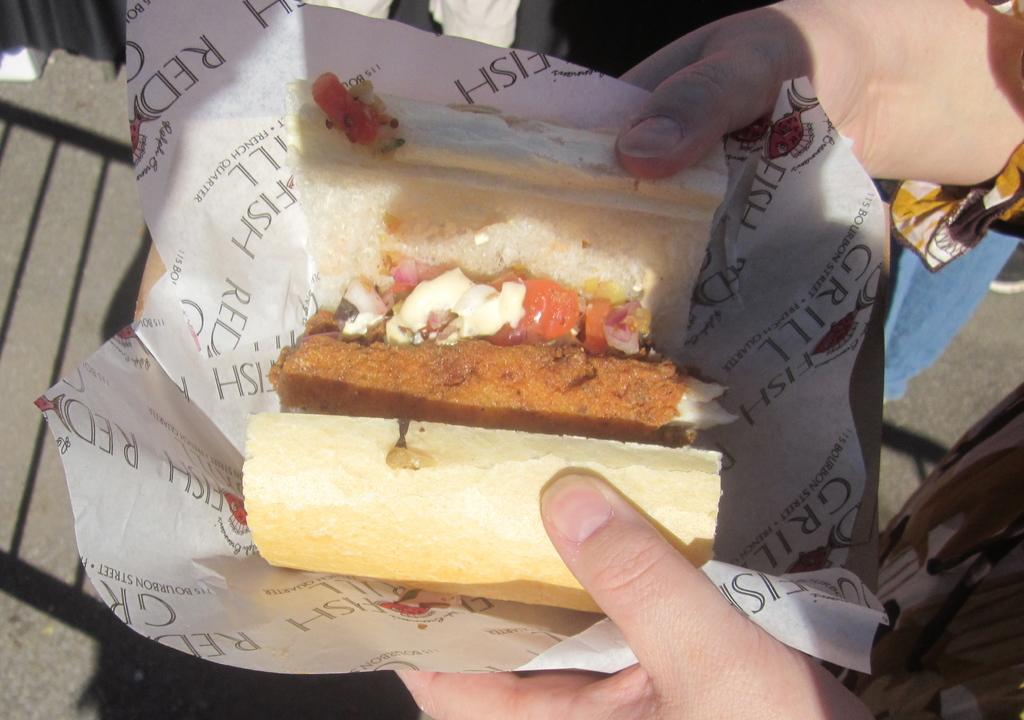Who or what is present in the image? There is a person in the image. What is the person holding in the image? The person is holding a paper. What can be seen on the paper that the person is holding? The paper contains images of food. What part of the person's body is visible in the image? The person's legs are visible in the image. What type of object can be seen in the background of the image? There is a black color curtain in the image. What color is the sweater the person is wearing in the image? The provided facts do not mention a sweater, so we cannot determine the color of a sweater in the image. What type of ink is used to draw the food images on the paper? The provided facts do not mention the type of ink used to draw the food images on the paper. 